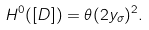<formula> <loc_0><loc_0><loc_500><loc_500>H ^ { 0 } ( [ D ] ) = \theta ( 2 y _ { \sigma } ) ^ { 2 } .</formula> 